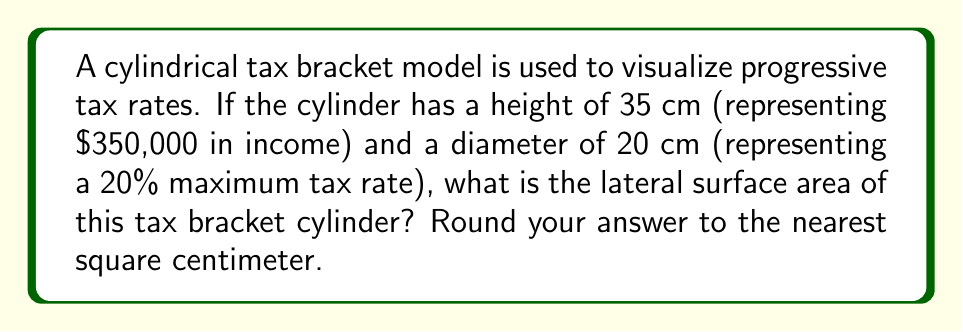Can you answer this question? To solve this problem, we need to follow these steps:

1. Recall the formula for the lateral surface area of a cylinder:
   $$ A = 2\pi rh $$
   where $A$ is the lateral surface area, $r$ is the radius, and $h$ is the height.

2. Identify the given values:
   - Height (h) = 35 cm
   - Diameter = 20 cm

3. Calculate the radius:
   $$ r = \frac{\text{diameter}}{2} = \frac{20}{2} = 10 \text{ cm} $$

4. Substitute the values into the formula:
   $$ A = 2\pi (10)(35) $$

5. Simplify:
   $$ A = 2\pi (350) = 700\pi \text{ cm}^2 $$

6. Calculate and round to the nearest square centimeter:
   $$ A \approx 2,199.11 \text{ cm}^2 \approx 2,199 \text{ cm}^2 $$

[asy]
import geometry;

size(200);
real r = 10;
real h = 35;

path p = (0,0)--(0,h)--(2*r,h)--(2*r,0)--cycle;
revolution cyl = revolution(p,Z);
draw(cyl,lightgray);
draw((-r,0)--(r,0),dashed);
draw((0,-r)--(0,r),dashed);
draw((0,h-r)--(0,h+r),dashed);

label("35 cm", (2*r+1,h/2), E);
label("20 cm", (0,-r-1), S);
[/asy]
Answer: The lateral surface area of the tax bracket cylinder is approximately 2,199 cm². 